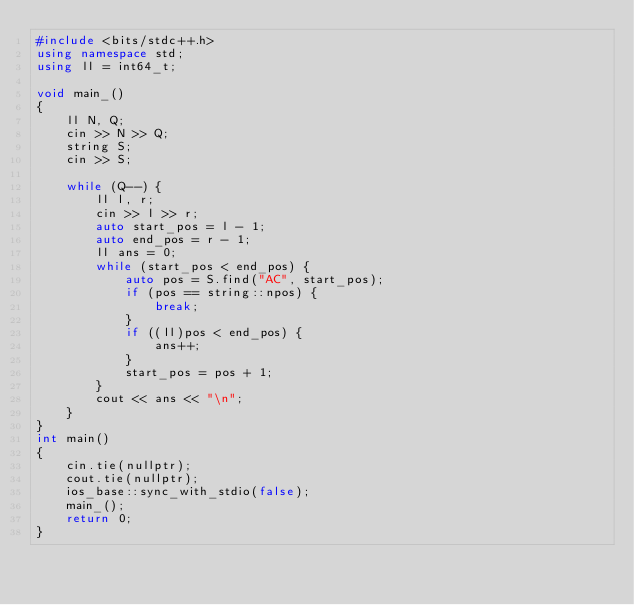Convert code to text. <code><loc_0><loc_0><loc_500><loc_500><_C++_>#include <bits/stdc++.h>
using namespace std;
using ll = int64_t;

void main_()
{
    ll N, Q;
    cin >> N >> Q;
    string S;
    cin >> S;

    while (Q--) {
        ll l, r;
        cin >> l >> r;
        auto start_pos = l - 1;
        auto end_pos = r - 1;
        ll ans = 0;
        while (start_pos < end_pos) {
            auto pos = S.find("AC", start_pos);
            if (pos == string::npos) {
                break;
            }
            if ((ll)pos < end_pos) {
                ans++;
            }
            start_pos = pos + 1;
        }
        cout << ans << "\n";
    }
}
int main()
{
    cin.tie(nullptr);
    cout.tie(nullptr);
    ios_base::sync_with_stdio(false);
    main_();
    return 0;
}
</code> 